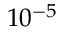<formula> <loc_0><loc_0><loc_500><loc_500>1 0 ^ { - 5 }</formula> 